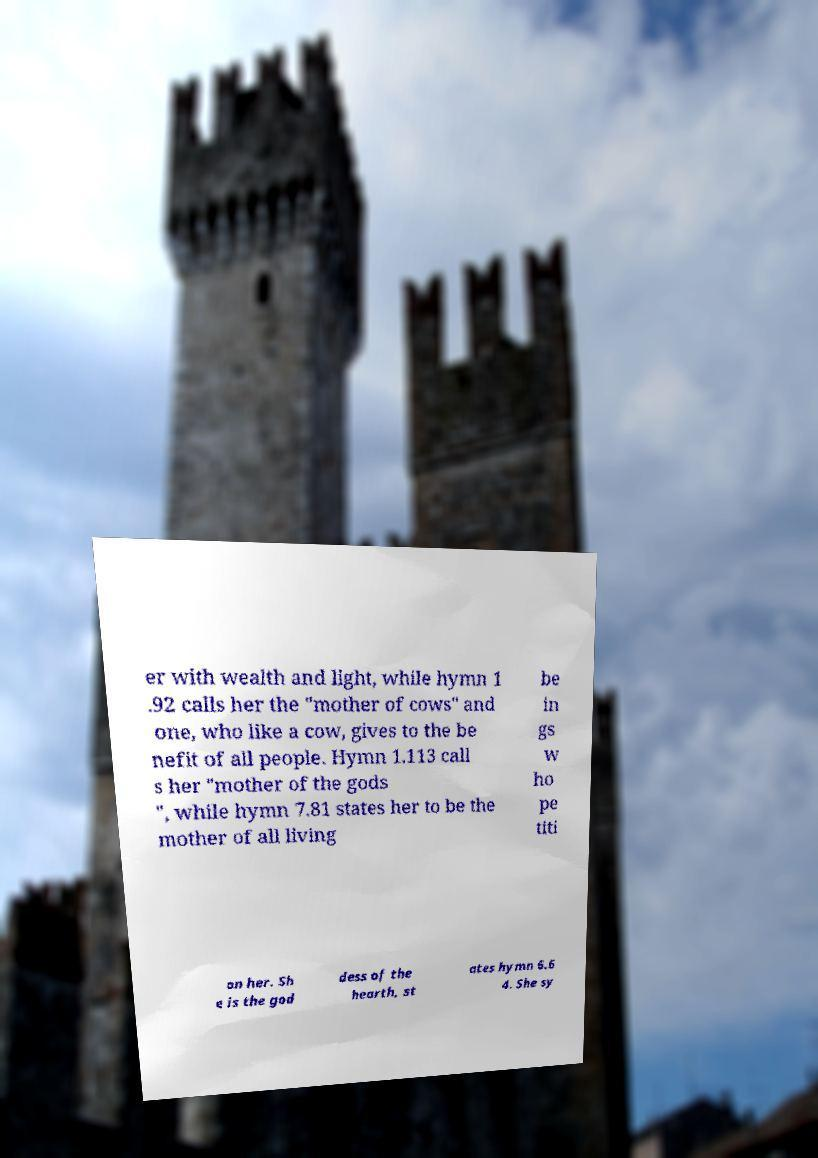Could you assist in decoding the text presented in this image and type it out clearly? er with wealth and light, while hymn 1 .92 calls her the "mother of cows" and one, who like a cow, gives to the be nefit of all people. Hymn 1.113 call s her "mother of the gods ", while hymn 7.81 states her to be the mother of all living be in gs w ho pe titi on her. Sh e is the god dess of the hearth, st ates hymn 6.6 4. She sy 